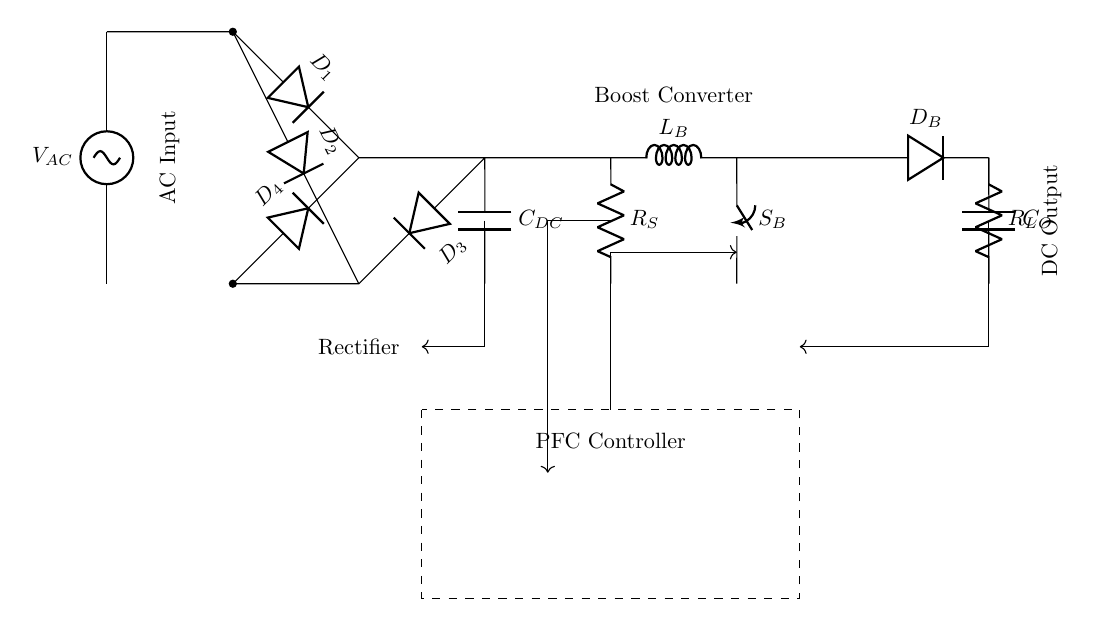What is the type of input voltage for this circuit? The circuit shows an AC source labeled as V_AC, indicating that it receives alternating current voltage.
Answer: AC What do the components labeled with D represent in the circuit? The components labeled with D are diodes, specifically D1, D2, D3, and D4, which form the bridge rectifier that converts AC to DC voltage.
Answer: Diodes What is the function of the C_DC component in this circuit? C_DC represents the DC link capacitor, which smooths the output voltage from the rectifier and helps maintain a stable voltage level.
Answer: Smoothing How does the boost converter affect the output voltage? The boost converter increases the DC voltage through the inductor L_B and switching element S_B, allowing for higher output voltage beyond the input voltage.
Answer: Increase What is the role of the PFC Controller in this circuit? The PFC Controller, which is bordered by the dashed box, regulates the input current and maintains the power factor to improve energy efficiency in the circuit.
Answer: Regulation What is the purpose of the output capacitor C_O in this setup? The output capacitor C_O helps filter and stabilize the voltage at the load R_L, ensuring a smoother supply for the connected equipment.
Answer: Stabilization What is indicated by the R_S component in the circuit? R_S represents a current sensor that measures the current flowing through the circuit, aiding in feedback for the PFC Controller to adjust operation.
Answer: Current sensing 